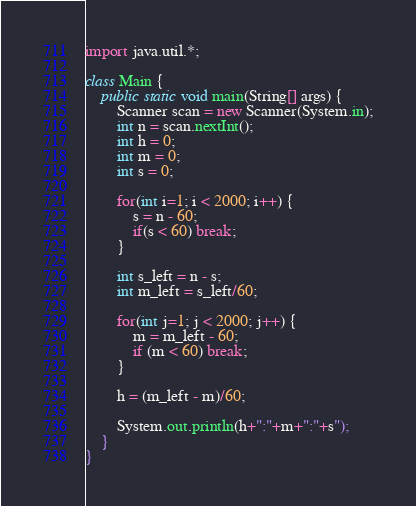Convert code to text. <code><loc_0><loc_0><loc_500><loc_500><_Java_>import java.util.*;

class Main {
    public static void main(String[] args) {
        Scanner scan = new Scanner(System.in);
        int n = scan.nextInt();
        int h = 0;
        int m = 0;
        int s = 0;

        for(int i=1; i < 2000; i++) {
            s = n - 60;
            if(s < 60) break;
        }
        
        int s_left = n - s;
        int m_left = s_left/60;
        
        for(int j=1; j < 2000; j++) {
            m = m_left - 60;
            if (m < 60) break;
        }

        h = (m_left - m)/60;

        System.out.println(h+":"+m+":"+s");
    }
}</code> 